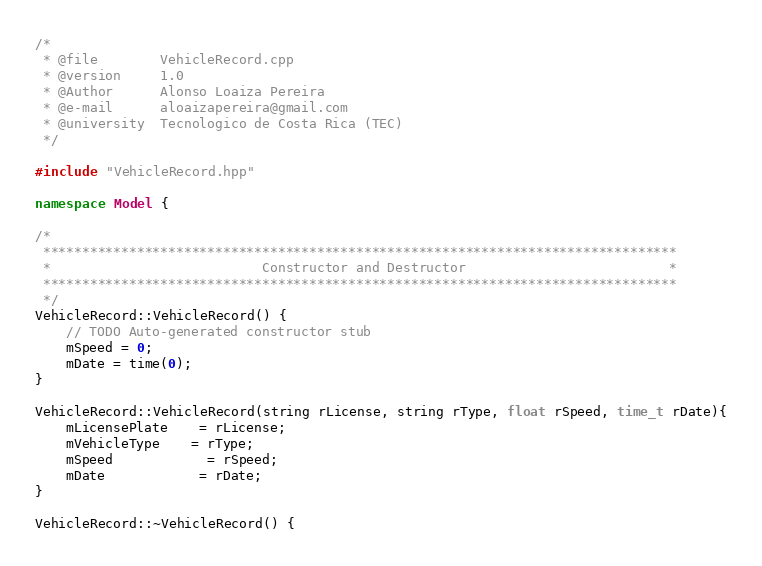<code> <loc_0><loc_0><loc_500><loc_500><_C++_>/*
 * @file 		VehicleRecord.cpp
 * @version 	1.0
 * @Author  	Alonso Loaiza Pereira
 * @e-mail  	aloaizapereira@gmail.com
 * @university 	Tecnologico de Costa Rica (TEC)
 */

#include "VehicleRecord.hpp"

namespace Model {

/*
 *********************************************************************************
 *                           Constructor and Destructor                          *
 *********************************************************************************
 */
VehicleRecord::VehicleRecord() {
	// TODO Auto-generated constructor stub
	mSpeed = 0;
	mDate = time(0);
}

VehicleRecord::VehicleRecord(string rLicense, string rType, float rSpeed, time_t rDate){
	mLicensePlate 	= rLicense;
	mVehicleType  	= rType;
	mSpeed 			= rSpeed;
	mDate 			= rDate;
}

VehicleRecord::~VehicleRecord() {</code> 